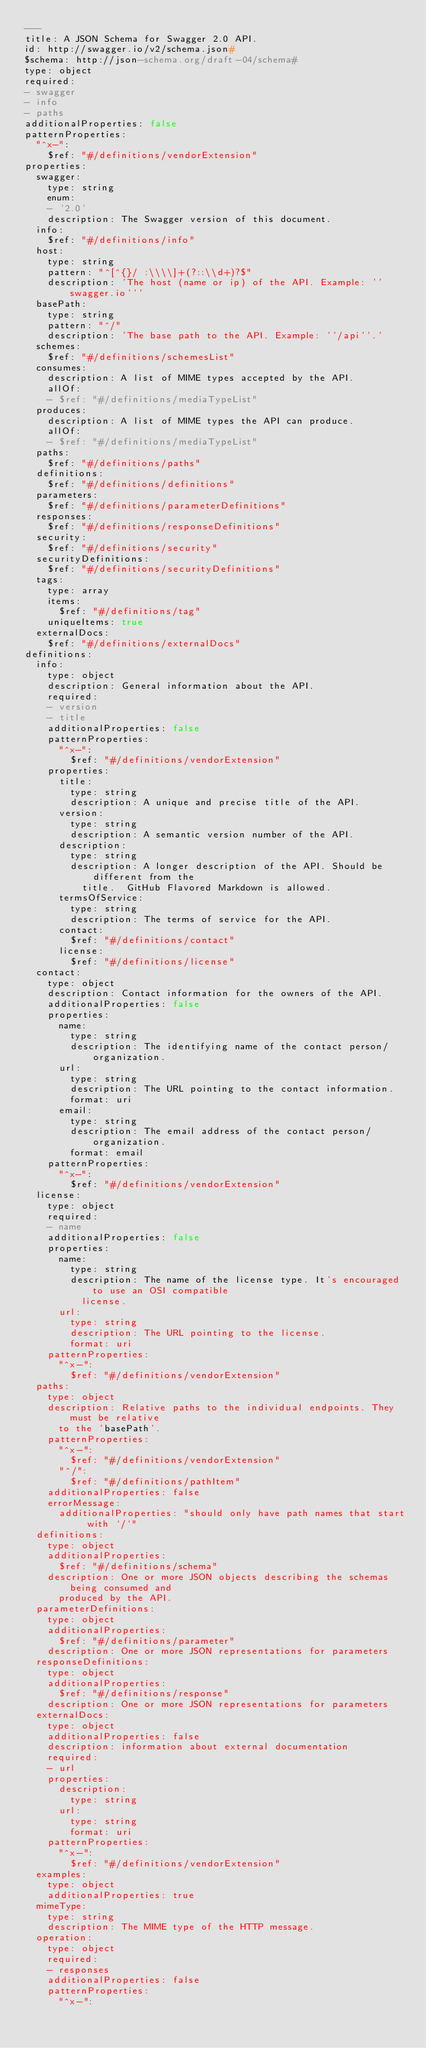Convert code to text. <code><loc_0><loc_0><loc_500><loc_500><_YAML_>---
title: A JSON Schema for Swagger 2.0 API.
id: http://swagger.io/v2/schema.json#
$schema: http://json-schema.org/draft-04/schema#
type: object
required:
- swagger
- info
- paths
additionalProperties: false
patternProperties:
  "^x-":
    $ref: "#/definitions/vendorExtension"
properties:
  swagger:
    type: string
    enum:
    - '2.0'
    description: The Swagger version of this document.
  info:
    $ref: "#/definitions/info"
  host:
    type: string
    pattern: "^[^{}/ :\\\\]+(?::\\d+)?$"
    description: 'The host (name or ip) of the API. Example: ''swagger.io'''
  basePath:
    type: string
    pattern: "^/"
    description: 'The base path to the API. Example: ''/api''.'
  schemes:
    $ref: "#/definitions/schemesList"
  consumes:
    description: A list of MIME types accepted by the API.
    allOf:
    - $ref: "#/definitions/mediaTypeList"
  produces:
    description: A list of MIME types the API can produce.
    allOf:
    - $ref: "#/definitions/mediaTypeList"
  paths:
    $ref: "#/definitions/paths"
  definitions:
    $ref: "#/definitions/definitions"
  parameters:
    $ref: "#/definitions/parameterDefinitions"
  responses:
    $ref: "#/definitions/responseDefinitions"
  security:
    $ref: "#/definitions/security"
  securityDefinitions:
    $ref: "#/definitions/securityDefinitions"
  tags:
    type: array
    items:
      $ref: "#/definitions/tag"
    uniqueItems: true
  externalDocs:
    $ref: "#/definitions/externalDocs"
definitions:
  info:
    type: object
    description: General information about the API.
    required:
    - version
    - title
    additionalProperties: false
    patternProperties:
      "^x-":
        $ref: "#/definitions/vendorExtension"
    properties:
      title:
        type: string
        description: A unique and precise title of the API.
      version:
        type: string
        description: A semantic version number of the API.
      description:
        type: string
        description: A longer description of the API. Should be different from the
          title.  GitHub Flavored Markdown is allowed.
      termsOfService:
        type: string
        description: The terms of service for the API.
      contact:
        $ref: "#/definitions/contact"
      license:
        $ref: "#/definitions/license"
  contact:
    type: object
    description: Contact information for the owners of the API.
    additionalProperties: false
    properties:
      name:
        type: string
        description: The identifying name of the contact person/organization.
      url:
        type: string
        description: The URL pointing to the contact information.
        format: uri
      email:
        type: string
        description: The email address of the contact person/organization.
        format: email
    patternProperties:
      "^x-":
        $ref: "#/definitions/vendorExtension"
  license:
    type: object
    required:
    - name
    additionalProperties: false
    properties:
      name:
        type: string
        description: The name of the license type. It's encouraged to use an OSI compatible
          license.
      url:
        type: string
        description: The URL pointing to the license.
        format: uri
    patternProperties:
      "^x-":
        $ref: "#/definitions/vendorExtension"
  paths:
    type: object
    description: Relative paths to the individual endpoints. They must be relative
      to the 'basePath'.
    patternProperties:
      "^x-":
        $ref: "#/definitions/vendorExtension"
      "^/":
        $ref: "#/definitions/pathItem"
    additionalProperties: false
    errorMessage:
      additionalProperties: "should only have path names that start with `/`"
  definitions:
    type: object
    additionalProperties:
      $ref: "#/definitions/schema"
    description: One or more JSON objects describing the schemas being consumed and
      produced by the API.
  parameterDefinitions:
    type: object
    additionalProperties:
      $ref: "#/definitions/parameter"
    description: One or more JSON representations for parameters
  responseDefinitions:
    type: object
    additionalProperties:
      $ref: "#/definitions/response"
    description: One or more JSON representations for parameters
  externalDocs:
    type: object
    additionalProperties: false
    description: information about external documentation
    required:
    - url
    properties:
      description:
        type: string
      url:
        type: string
        format: uri
    patternProperties:
      "^x-":
        $ref: "#/definitions/vendorExtension"
  examples:
    type: object
    additionalProperties: true
  mimeType:
    type: string
    description: The MIME type of the HTTP message.
  operation:
    type: object
    required:
    - responses
    additionalProperties: false
    patternProperties:
      "^x-":</code> 